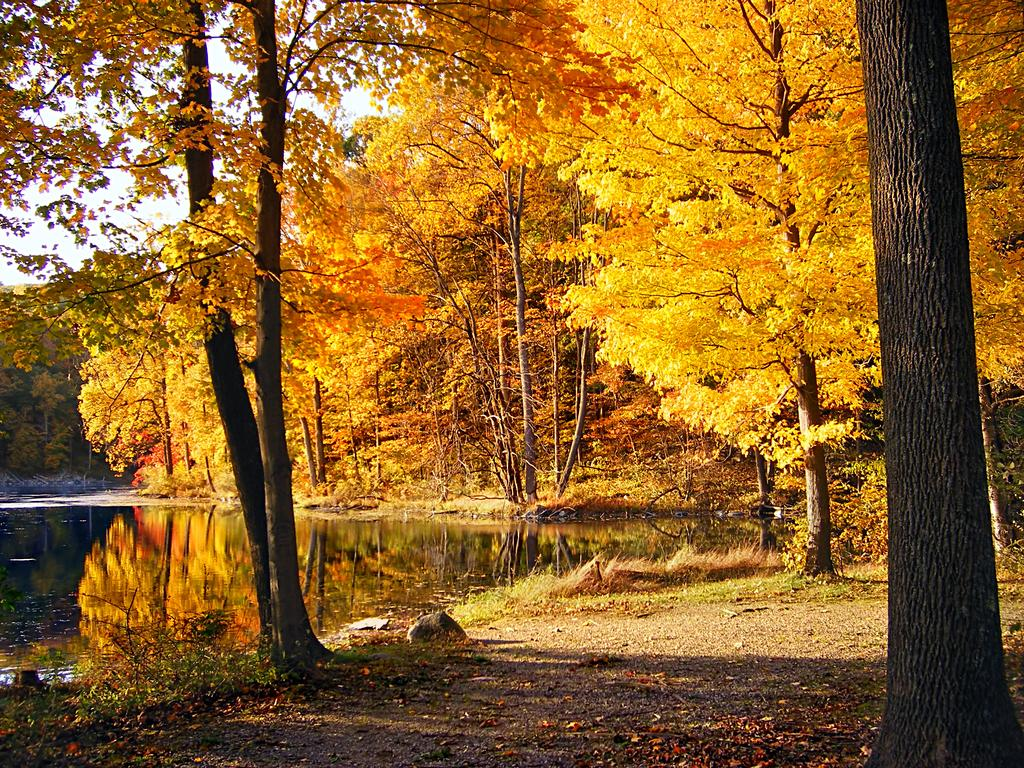What type of vegetation can be seen in the image? There are trees in the image. What colors are the trees? The trees are in yellow and orange colors. What is visible to the left of the image? There is water visible to the left of the image. What can be seen in the background of the image? The sky is visible in the background of the image. How many brothers are depicted in the image? There are no brothers present in the image; it features trees, water, and the sky. What type of organization is responsible for the trees in the image? There is no information about any organization responsible for the trees in the image. 